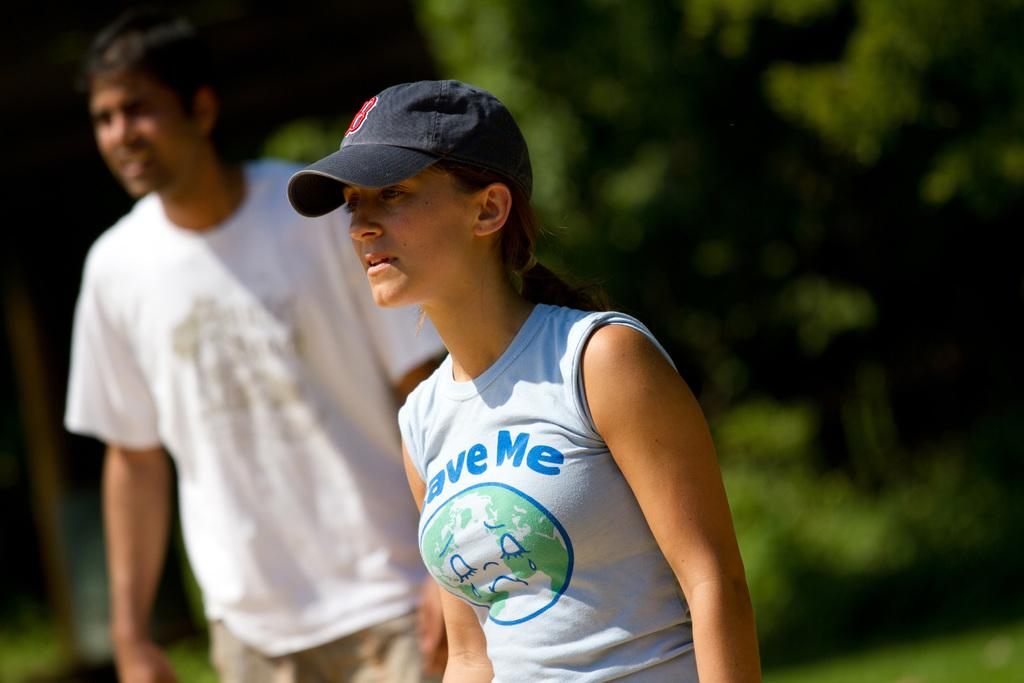<image>
Create a compact narrative representing the image presented. A young woman sports a blue ball cap and a t-shirt reading Save Me. 